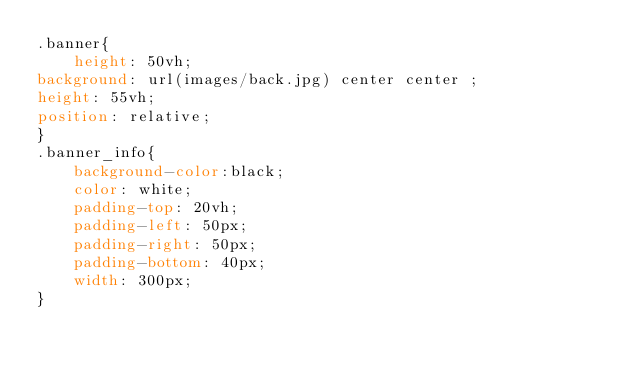Convert code to text. <code><loc_0><loc_0><loc_500><loc_500><_CSS_>.banner{
    height: 50vh;
background: url(images/back.jpg) center center ;
height: 55vh;
position: relative;
}
.banner_info{
    background-color:black;
    color: white;
    padding-top: 20vh;
    padding-left: 50px;
    padding-right: 50px;
    padding-bottom: 40px;
    width: 300px;
}</code> 